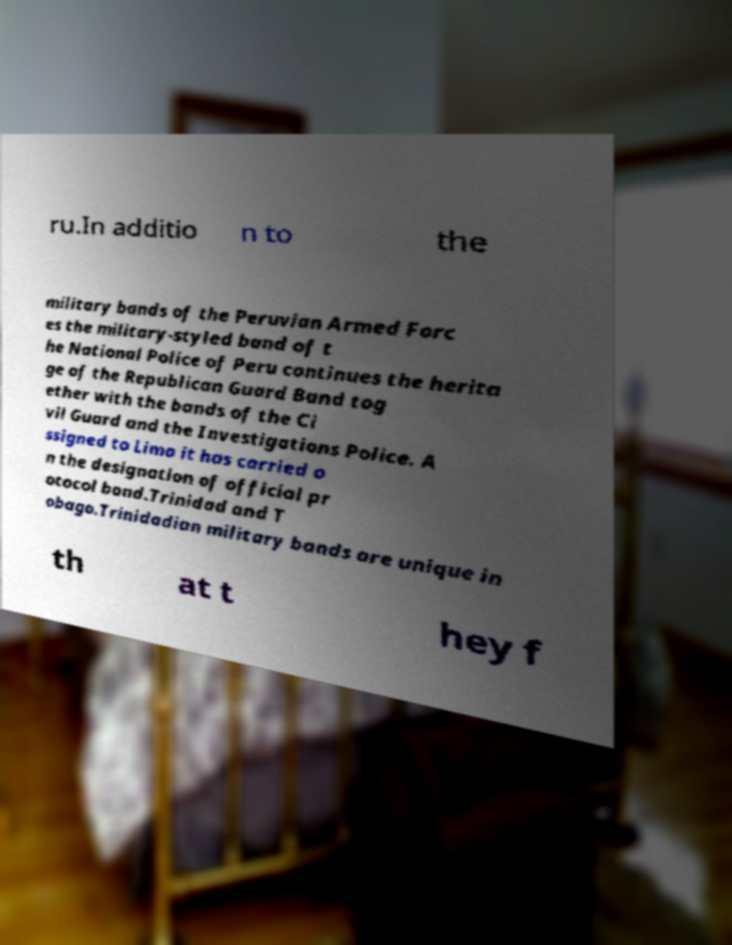What messages or text are displayed in this image? I need them in a readable, typed format. ru.In additio n to the military bands of the Peruvian Armed Forc es the military-styled band of t he National Police of Peru continues the herita ge of the Republican Guard Band tog ether with the bands of the Ci vil Guard and the Investigations Police. A ssigned to Lima it has carried o n the designation of official pr otocol band.Trinidad and T obago.Trinidadian military bands are unique in th at t hey f 